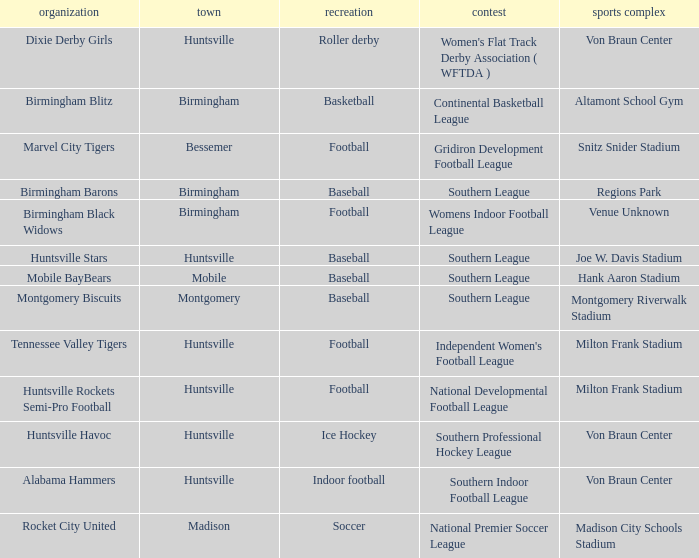Which venue held a basketball team? Altamont School Gym. 